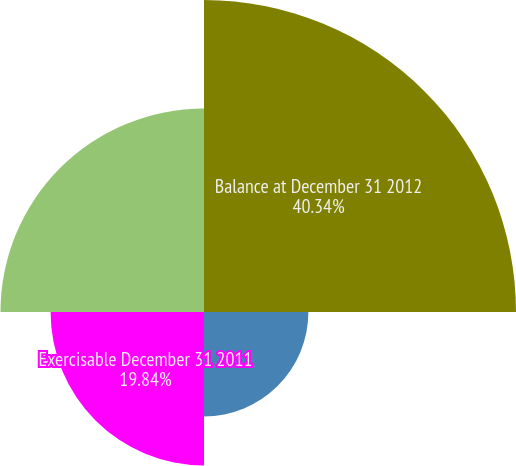<chart> <loc_0><loc_0><loc_500><loc_500><pie_chart><fcel>Balance at December 31 2012<fcel>Exercisable December 31 2010<fcel>Exercisable December 31 2011<fcel>Exercisable December 31 2012<nl><fcel>40.35%<fcel>13.5%<fcel>19.84%<fcel>26.32%<nl></chart> 